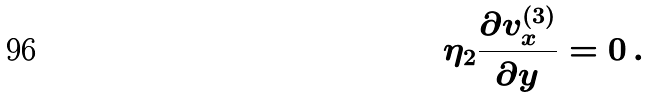<formula> <loc_0><loc_0><loc_500><loc_500>\eta _ { 2 } \frac { \partial v ^ { ( 3 ) } _ { x } } { \partial y } = 0 \, .</formula> 